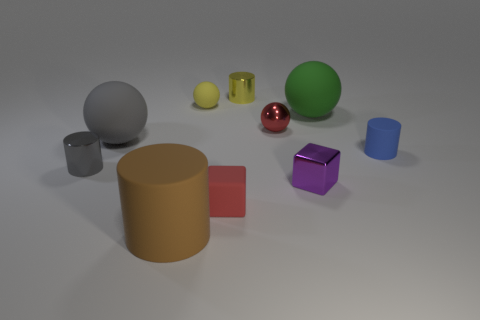Subtract all blocks. How many objects are left? 8 Add 3 tiny red objects. How many tiny red objects are left? 5 Add 8 metal cylinders. How many metal cylinders exist? 10 Subtract 0 green cylinders. How many objects are left? 10 Subtract all small red shiny cylinders. Subtract all large cylinders. How many objects are left? 9 